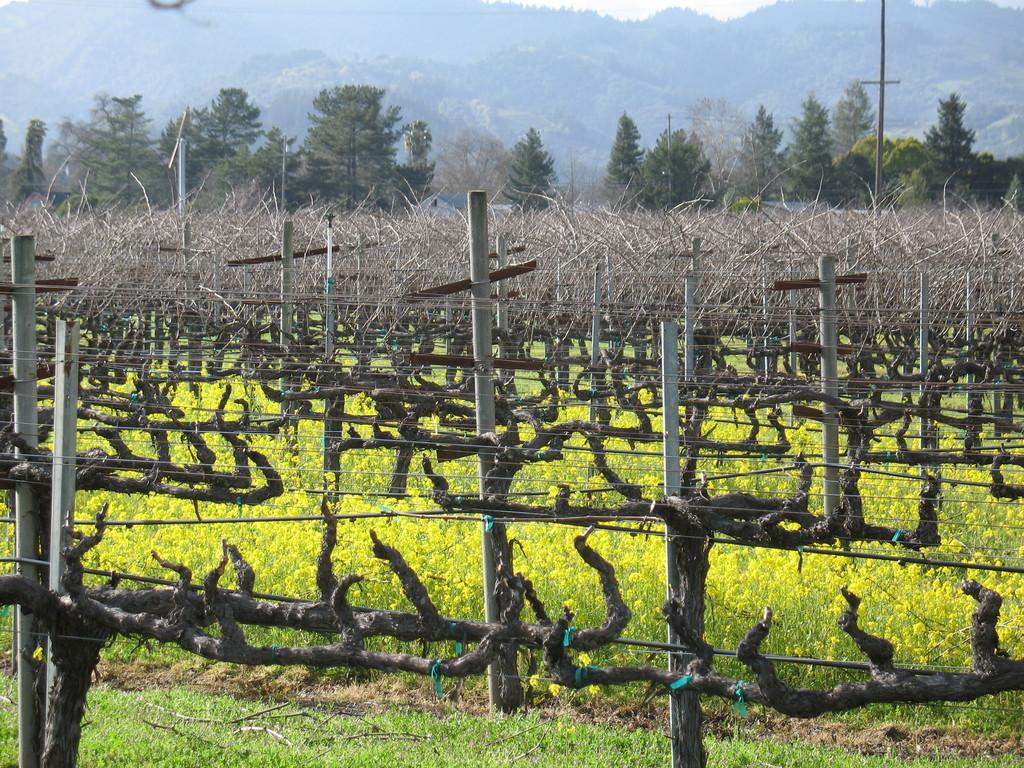What can be seen in the image that is related to infrastructure? There are poles and wires in the image. What type of natural environment is visible at the bottom of the image? There is grass at the bottom of the image. What type of vegetation is present in the image? There are plants in the image. What can be seen in the distance in the image? There are trees in the background of the image. How many pins are holding the trees in place in the image? There are no pins present in the image; the trees are standing on their own. What type of bird can be seen perched on the crow in the image? There is no crow present in the image, only trees and vegetation. 